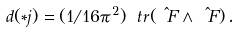Convert formula to latex. <formula><loc_0><loc_0><loc_500><loc_500>d ( \ast j ) = ( 1 / 1 6 \pi ^ { 2 } ) \ t r ( \hat { \ F } \wedge \hat { \ F } ) \, .</formula> 